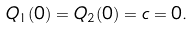Convert formula to latex. <formula><loc_0><loc_0><loc_500><loc_500>Q _ { 1 } ( 0 ) = Q _ { 2 } ( 0 ) = c = 0 .</formula> 